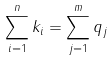Convert formula to latex. <formula><loc_0><loc_0><loc_500><loc_500>\sum _ { i = 1 } ^ { n } k _ { i } = \sum _ { j = 1 } ^ { m } q _ { j }</formula> 